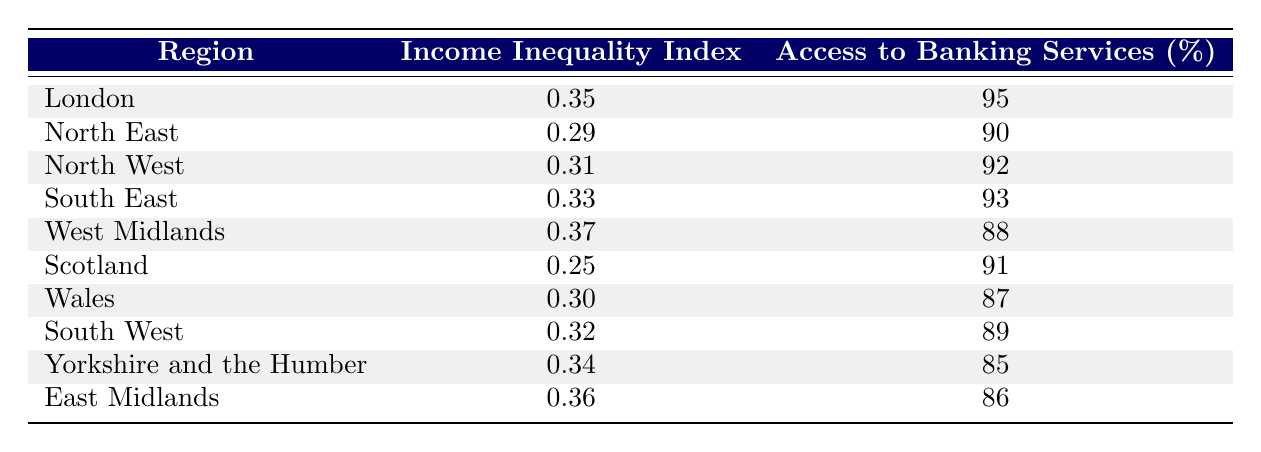What is the Income Inequality Index for London? The table indicates that the Income Inequality Index for London is listed directly as 0.35.
Answer: 0.35 What percentage of access to banking services does the South West have? According to the table, the South West has a percentage access to banking services of 89, which is explicitly stated.
Answer: 89 Which region has the highest Income Inequality Index? By comparing the values in the Income Inequality Index column, the West Midlands has the highest value of 0.37.
Answer: West Midlands Is the percentage access to banking services in Scotland higher than in Wales? The table shows that Scotland has 91% access while Wales has 87%, thus Scotland's access is higher.
Answer: Yes What is the average Income Inequality Index for the regions listed? To find the average, I sum the indexes (0.35 + 0.29 + 0.31 + 0.33 + 0.37 + 0.25 + 0.30 + 0.32 + 0.34 + 0.36 = 3.11) and divide by the number of regions (10). This gives an average of 3.11/10, which equals 0.311.
Answer: 0.311 Which region has the lowest access to banking services, and what is that percentage? The table shows that Yorkshire and the Humber has the lowest access at 85%, looking specifically at the "Access to Banking Services" column.
Answer: Yorkshire and the Humber, 85 Do regions with higher Income Inequality Index generally have lower access to banking services? Observing the table, the regions with higher inequality (like the West Midlands at 0.37) have lower banking access (88%), while those with lower inequality like Scotland (0.25) have 91%, indicating a general trend.
Answer: Yes What is the difference in access to banking services between the region with the highest and the lowest percentage? The highest percentage (London, 95) minus the lowest (Yorkshire and the Humber, 85) gives a difference of 10%. Thus, the difference in access to banking services is 10%.
Answer: 10% 